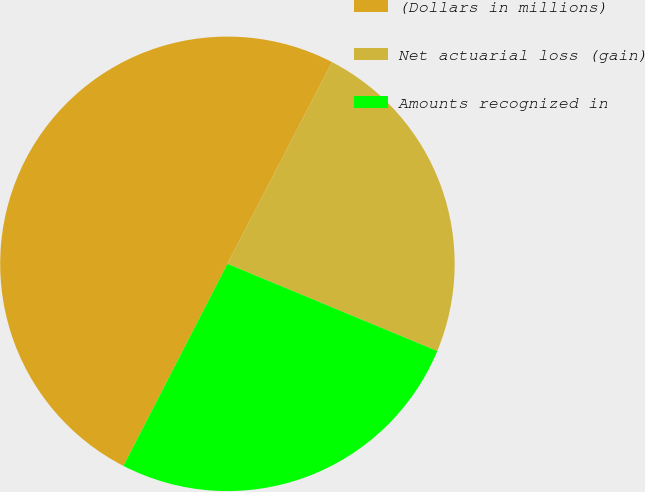Convert chart. <chart><loc_0><loc_0><loc_500><loc_500><pie_chart><fcel>(Dollars in millions)<fcel>Net actuarial loss (gain)<fcel>Amounts recognized in<nl><fcel>50.05%<fcel>23.66%<fcel>26.3%<nl></chart> 